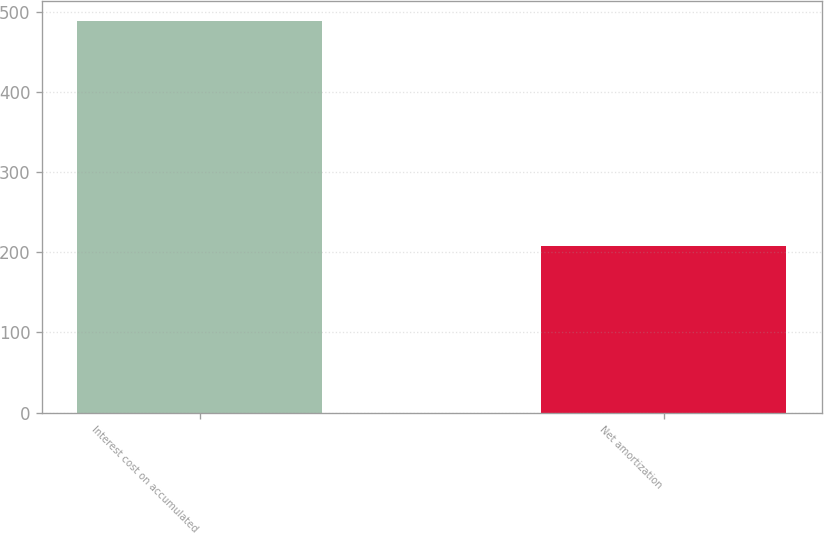Convert chart. <chart><loc_0><loc_0><loc_500><loc_500><bar_chart><fcel>Interest cost on accumulated<fcel>Net amortization<nl><fcel>489<fcel>208<nl></chart> 